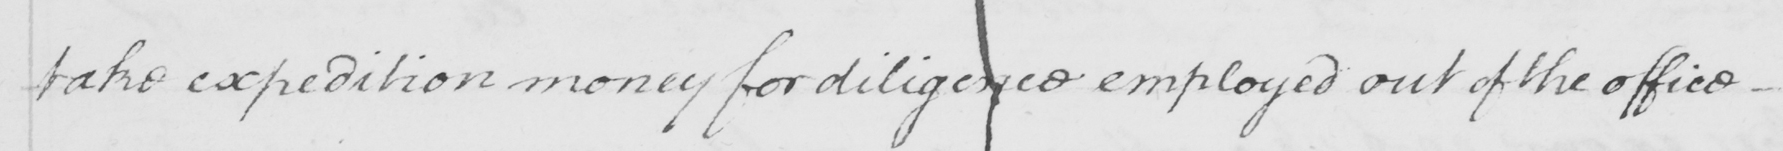What does this handwritten line say? take expedition money for diligence employed out of the office 